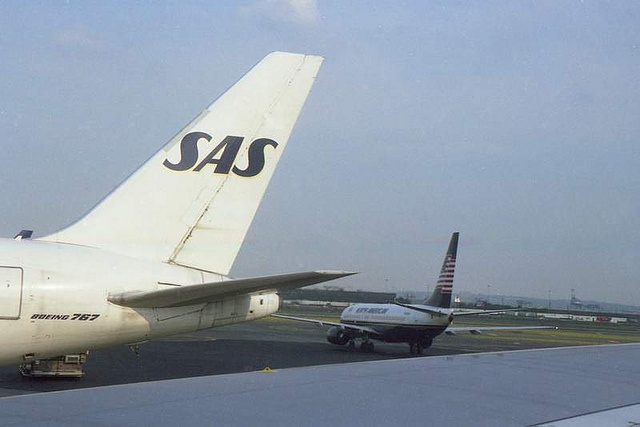Describe the objects in this image and their specific colors. I can see airplane in darkgray, ivory, gray, and beige tones and airplane in darkgray, black, and gray tones in this image. 